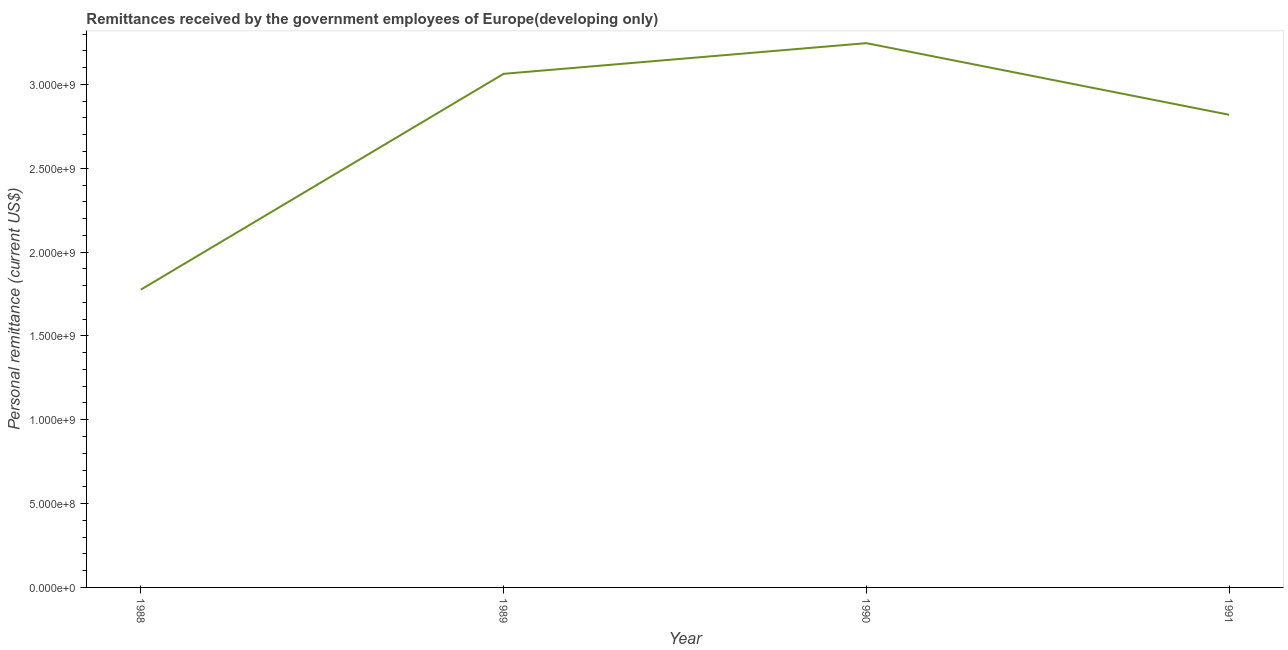What is the personal remittances in 1988?
Make the answer very short. 1.78e+09. Across all years, what is the maximum personal remittances?
Provide a succinct answer. 3.25e+09. Across all years, what is the minimum personal remittances?
Your answer should be compact. 1.78e+09. In which year was the personal remittances maximum?
Make the answer very short. 1990. In which year was the personal remittances minimum?
Offer a very short reply. 1988. What is the sum of the personal remittances?
Your response must be concise. 1.09e+1. What is the difference between the personal remittances in 1988 and 1991?
Provide a short and direct response. -1.04e+09. What is the average personal remittances per year?
Offer a very short reply. 2.73e+09. What is the median personal remittances?
Offer a terse response. 2.94e+09. In how many years, is the personal remittances greater than 100000000 US$?
Keep it short and to the point. 4. What is the ratio of the personal remittances in 1988 to that in 1991?
Your answer should be very brief. 0.63. What is the difference between the highest and the second highest personal remittances?
Offer a terse response. 1.83e+08. Is the sum of the personal remittances in 1989 and 1991 greater than the maximum personal remittances across all years?
Ensure brevity in your answer.  Yes. What is the difference between the highest and the lowest personal remittances?
Provide a short and direct response. 1.47e+09. How many lines are there?
Offer a very short reply. 1. How many years are there in the graph?
Ensure brevity in your answer.  4. Are the values on the major ticks of Y-axis written in scientific E-notation?
Offer a terse response. Yes. Does the graph contain any zero values?
Provide a succinct answer. No. What is the title of the graph?
Give a very brief answer. Remittances received by the government employees of Europe(developing only). What is the label or title of the X-axis?
Provide a short and direct response. Year. What is the label or title of the Y-axis?
Offer a terse response. Personal remittance (current US$). What is the Personal remittance (current US$) in 1988?
Your response must be concise. 1.78e+09. What is the Personal remittance (current US$) of 1989?
Your answer should be very brief. 3.06e+09. What is the Personal remittance (current US$) in 1990?
Make the answer very short. 3.25e+09. What is the Personal remittance (current US$) in 1991?
Keep it short and to the point. 2.82e+09. What is the difference between the Personal remittance (current US$) in 1988 and 1989?
Provide a short and direct response. -1.29e+09. What is the difference between the Personal remittance (current US$) in 1988 and 1990?
Make the answer very short. -1.47e+09. What is the difference between the Personal remittance (current US$) in 1988 and 1991?
Your answer should be very brief. -1.04e+09. What is the difference between the Personal remittance (current US$) in 1989 and 1990?
Offer a terse response. -1.83e+08. What is the difference between the Personal remittance (current US$) in 1989 and 1991?
Your answer should be compact. 2.44e+08. What is the difference between the Personal remittance (current US$) in 1990 and 1991?
Offer a terse response. 4.27e+08. What is the ratio of the Personal remittance (current US$) in 1988 to that in 1989?
Offer a very short reply. 0.58. What is the ratio of the Personal remittance (current US$) in 1988 to that in 1990?
Your answer should be very brief. 0.55. What is the ratio of the Personal remittance (current US$) in 1988 to that in 1991?
Make the answer very short. 0.63. What is the ratio of the Personal remittance (current US$) in 1989 to that in 1990?
Make the answer very short. 0.94. What is the ratio of the Personal remittance (current US$) in 1989 to that in 1991?
Give a very brief answer. 1.09. What is the ratio of the Personal remittance (current US$) in 1990 to that in 1991?
Your answer should be compact. 1.15. 